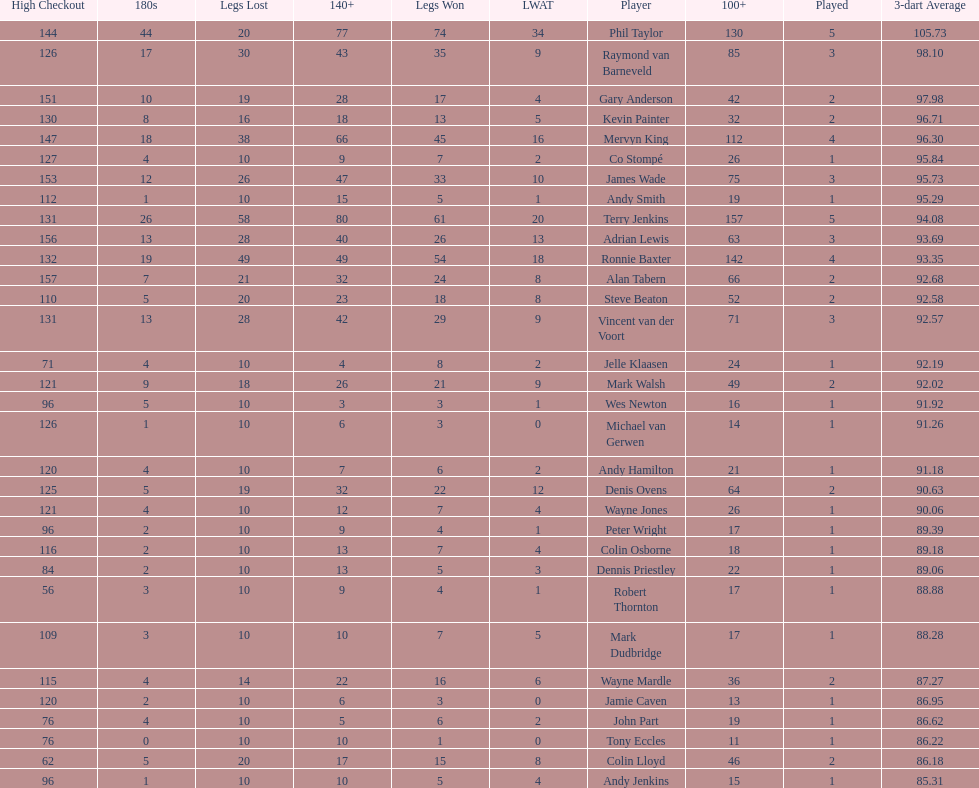How many players in the 2009 world matchplay won at least 30 legs? 6. 